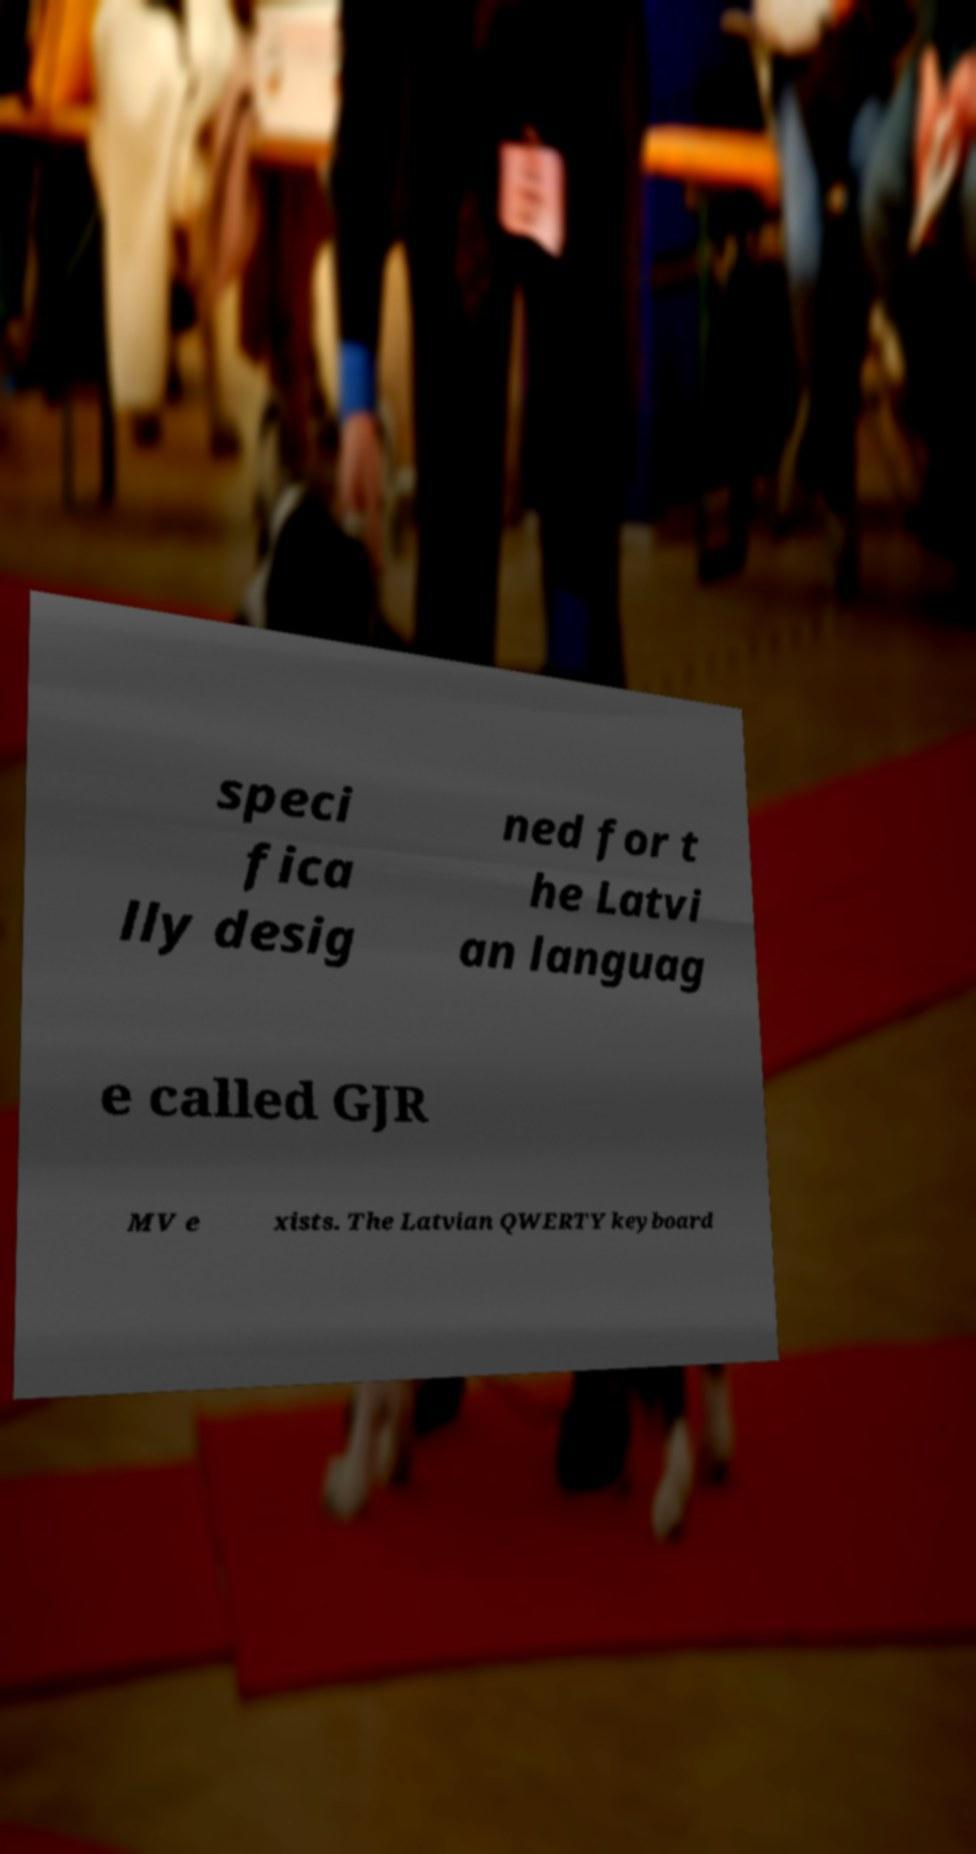Please read and relay the text visible in this image. What does it say? speci fica lly desig ned for t he Latvi an languag e called GJR MV e xists. The Latvian QWERTY keyboard 